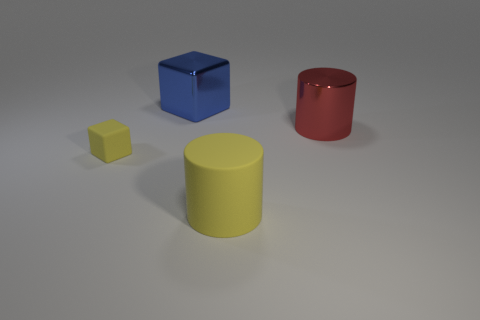Add 4 green metal cubes. How many objects exist? 8 Subtract 1 cylinders. How many cylinders are left? 1 Subtract all cyan cylinders. Subtract all brown cubes. How many cylinders are left? 2 Subtract all brown blocks. How many yellow cylinders are left? 1 Subtract all big yellow things. Subtract all matte objects. How many objects are left? 1 Add 2 tiny things. How many tiny things are left? 3 Add 1 big red matte spheres. How many big red matte spheres exist? 1 Subtract 1 yellow cylinders. How many objects are left? 3 